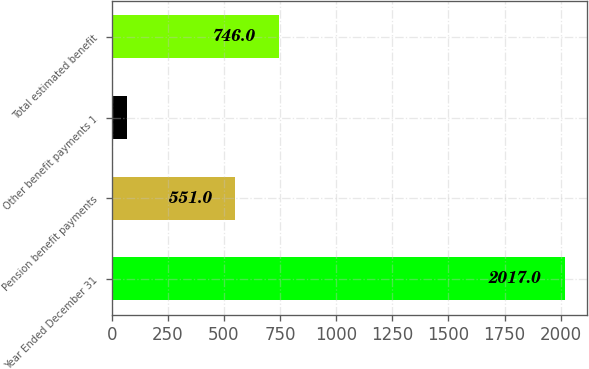Convert chart. <chart><loc_0><loc_0><loc_500><loc_500><bar_chart><fcel>Year Ended December 31<fcel>Pension benefit payments<fcel>Other benefit payments 1<fcel>Total estimated benefit<nl><fcel>2017<fcel>551<fcel>67<fcel>746<nl></chart> 